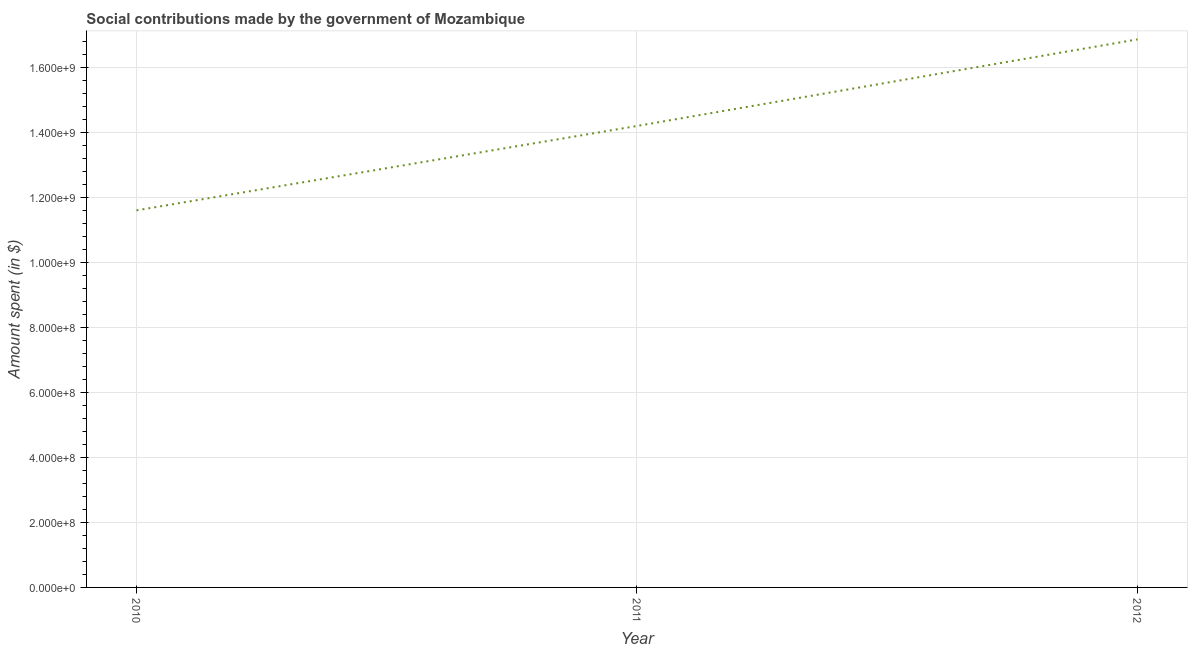What is the amount spent in making social contributions in 2011?
Keep it short and to the point. 1.42e+09. Across all years, what is the maximum amount spent in making social contributions?
Offer a very short reply. 1.69e+09. Across all years, what is the minimum amount spent in making social contributions?
Make the answer very short. 1.16e+09. In which year was the amount spent in making social contributions maximum?
Your answer should be compact. 2012. What is the sum of the amount spent in making social contributions?
Your response must be concise. 4.27e+09. What is the difference between the amount spent in making social contributions in 2010 and 2011?
Offer a terse response. -2.60e+08. What is the average amount spent in making social contributions per year?
Make the answer very short. 1.42e+09. What is the median amount spent in making social contributions?
Provide a short and direct response. 1.42e+09. Do a majority of the years between 2011 and 2012 (inclusive) have amount spent in making social contributions greater than 720000000 $?
Your answer should be compact. Yes. What is the ratio of the amount spent in making social contributions in 2011 to that in 2012?
Your answer should be very brief. 0.84. What is the difference between the highest and the second highest amount spent in making social contributions?
Your answer should be compact. 2.67e+08. What is the difference between the highest and the lowest amount spent in making social contributions?
Your response must be concise. 5.26e+08. In how many years, is the amount spent in making social contributions greater than the average amount spent in making social contributions taken over all years?
Offer a terse response. 1. Does the amount spent in making social contributions monotonically increase over the years?
Give a very brief answer. Yes. What is the difference between two consecutive major ticks on the Y-axis?
Give a very brief answer. 2.00e+08. Does the graph contain any zero values?
Offer a terse response. No. What is the title of the graph?
Ensure brevity in your answer.  Social contributions made by the government of Mozambique. What is the label or title of the X-axis?
Ensure brevity in your answer.  Year. What is the label or title of the Y-axis?
Offer a terse response. Amount spent (in $). What is the Amount spent (in $) of 2010?
Ensure brevity in your answer.  1.16e+09. What is the Amount spent (in $) of 2011?
Offer a terse response. 1.42e+09. What is the Amount spent (in $) of 2012?
Make the answer very short. 1.69e+09. What is the difference between the Amount spent (in $) in 2010 and 2011?
Offer a terse response. -2.60e+08. What is the difference between the Amount spent (in $) in 2010 and 2012?
Offer a very short reply. -5.26e+08. What is the difference between the Amount spent (in $) in 2011 and 2012?
Ensure brevity in your answer.  -2.67e+08. What is the ratio of the Amount spent (in $) in 2010 to that in 2011?
Provide a succinct answer. 0.82. What is the ratio of the Amount spent (in $) in 2010 to that in 2012?
Your answer should be compact. 0.69. What is the ratio of the Amount spent (in $) in 2011 to that in 2012?
Offer a very short reply. 0.84. 